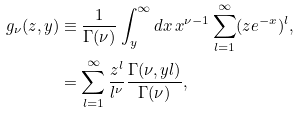<formula> <loc_0><loc_0><loc_500><loc_500>g _ { \nu } ( z , y ) & \equiv \frac { 1 } { \Gamma ( \nu ) } \int _ { y } ^ { \infty } d x \, x ^ { \nu - 1 } \sum _ { l = 1 } ^ { \infty } ( z e ^ { - x } ) ^ { l } , \\ & = \sum _ { l = 1 } ^ { \infty } \frac { z ^ { l } } { l ^ { \nu } } \frac { \Gamma ( \nu , y l ) } { \Gamma ( \nu ) } ,</formula> 